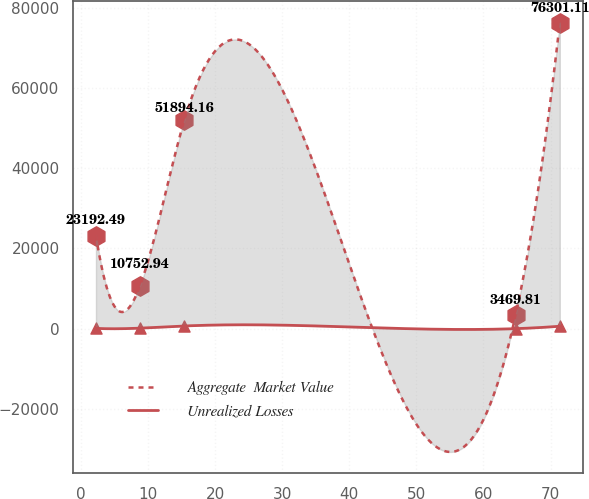Convert chart to OTSL. <chart><loc_0><loc_0><loc_500><loc_500><line_chart><ecel><fcel>Aggregate  Market Value<fcel>Unrealized Losses<nl><fcel>2.25<fcel>23192.5<fcel>64.67<nl><fcel>8.83<fcel>10752.9<fcel>128.34<nl><fcel>15.41<fcel>51894.2<fcel>666.23<nl><fcel>64.8<fcel>3469.81<fcel>1<nl><fcel>71.38<fcel>76301.1<fcel>602.56<nl></chart> 